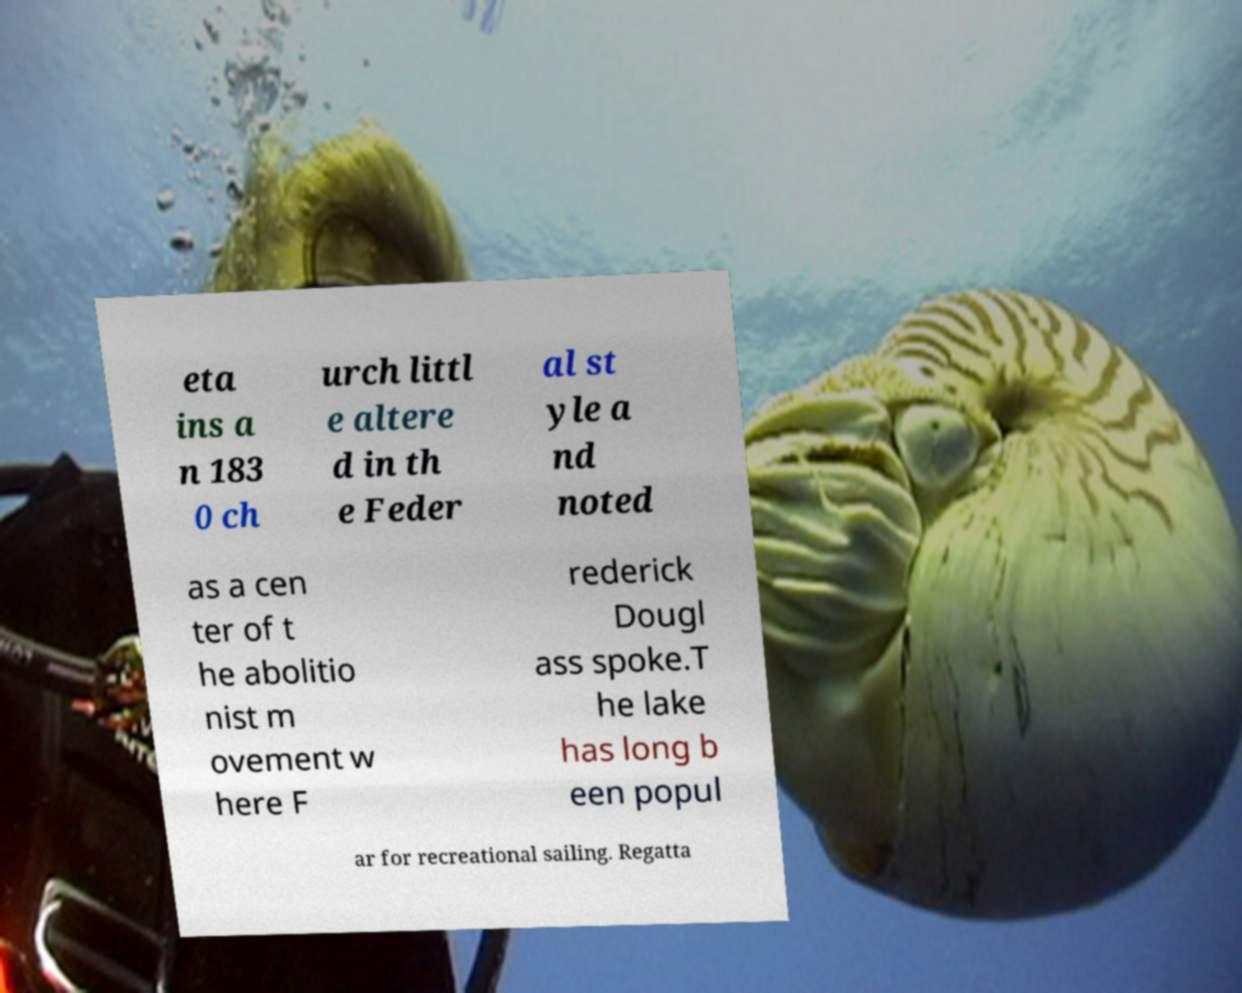I need the written content from this picture converted into text. Can you do that? eta ins a n 183 0 ch urch littl e altere d in th e Feder al st yle a nd noted as a cen ter of t he abolitio nist m ovement w here F rederick Dougl ass spoke.T he lake has long b een popul ar for recreational sailing. Regatta 